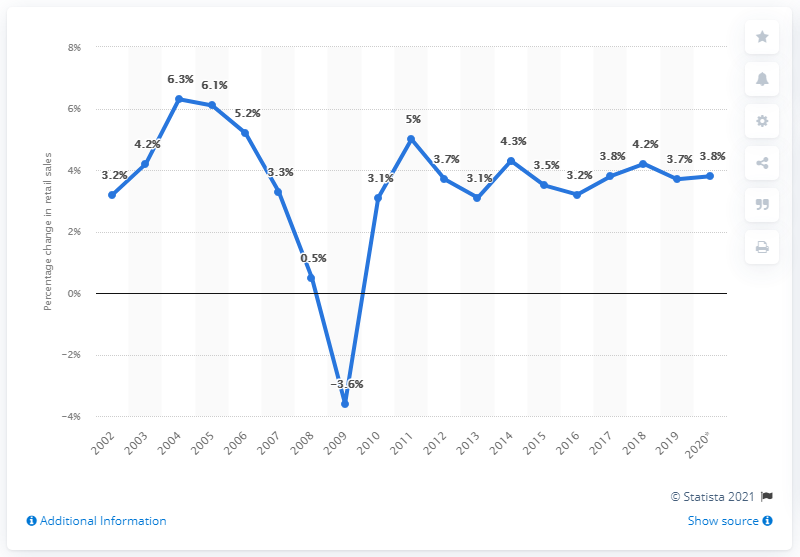Draw attention to some important aspects in this diagram. In 2019, the total retail sales grew by 3.7% compared to the previous year. 